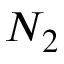Convert formula to latex. <formula><loc_0><loc_0><loc_500><loc_500>N _ { 2 }</formula> 